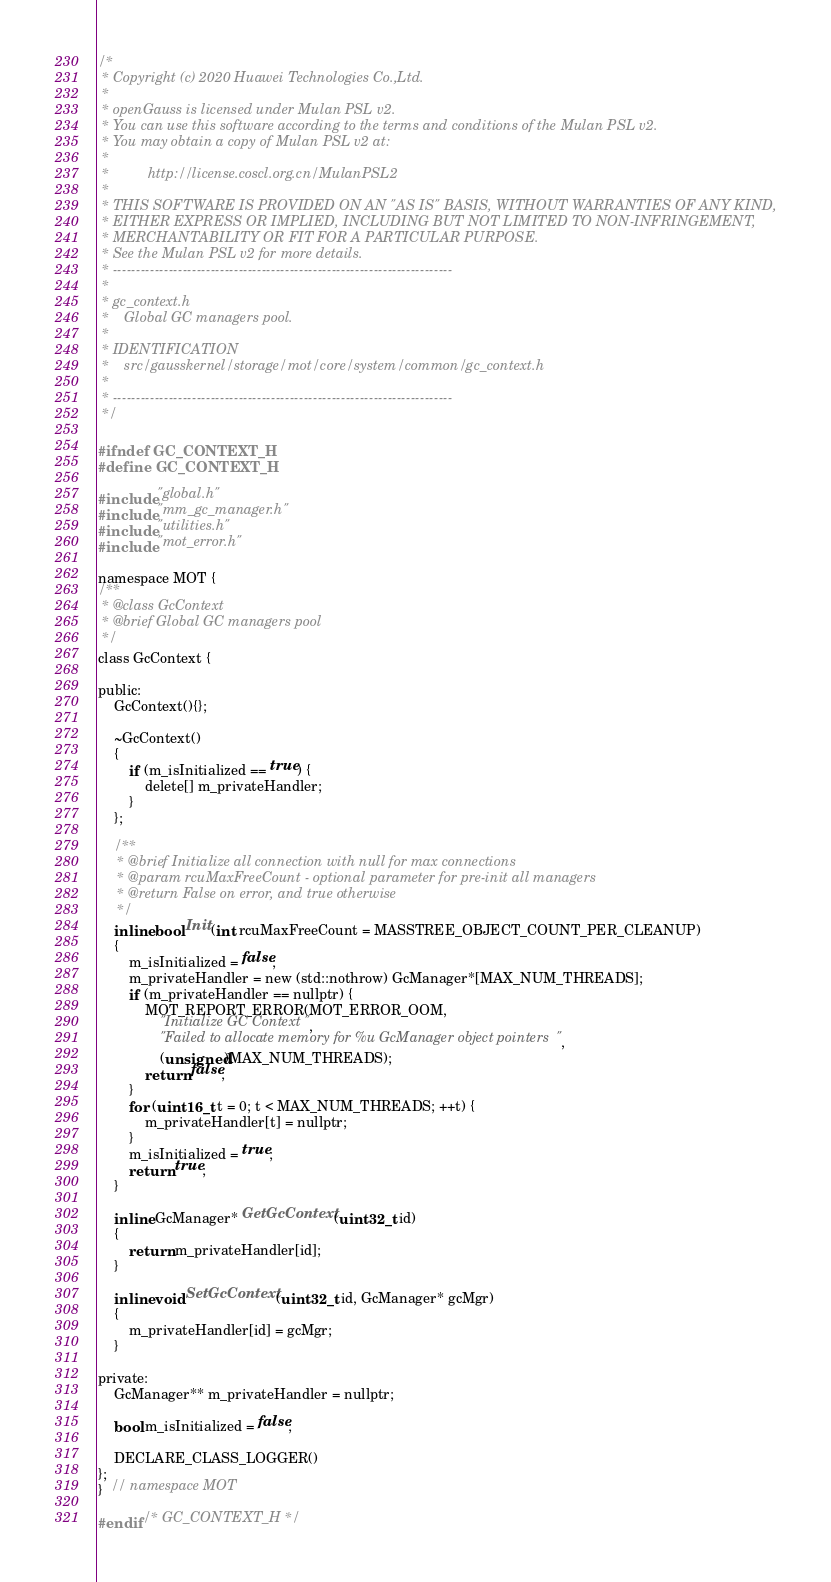<code> <loc_0><loc_0><loc_500><loc_500><_C_>/*
 * Copyright (c) 2020 Huawei Technologies Co.,Ltd.
 *
 * openGauss is licensed under Mulan PSL v2.
 * You can use this software according to the terms and conditions of the Mulan PSL v2.
 * You may obtain a copy of Mulan PSL v2 at:
 *
 *          http://license.coscl.org.cn/MulanPSL2
 *
 * THIS SOFTWARE IS PROVIDED ON AN "AS IS" BASIS, WITHOUT WARRANTIES OF ANY KIND,
 * EITHER EXPRESS OR IMPLIED, INCLUDING BUT NOT LIMITED TO NON-INFRINGEMENT,
 * MERCHANTABILITY OR FIT FOR A PARTICULAR PURPOSE.
 * See the Mulan PSL v2 for more details.
 * -------------------------------------------------------------------------
 *
 * gc_context.h
 *    Global GC managers pool.
 *
 * IDENTIFICATION
 *    src/gausskernel/storage/mot/core/system/common/gc_context.h
 *
 * -------------------------------------------------------------------------
 */

#ifndef GC_CONTEXT_H
#define GC_CONTEXT_H

#include "global.h"
#include "mm_gc_manager.h"
#include "utilities.h"
#include "mot_error.h"

namespace MOT {
/**
 * @class GcContext
 * @brief Global GC managers pool
 */
class GcContext {

public:
    GcContext(){};

    ~GcContext()
    {
        if (m_isInitialized == true) {
            delete[] m_privateHandler;
        }
    };

    /**
     * @brief Initialize all connection with null for max connections
     * @param rcuMaxFreeCount - optional parameter for pre-init all managers
     * @return False on error, and true otherwise
     */
    inline bool Init(int rcuMaxFreeCount = MASSTREE_OBJECT_COUNT_PER_CLEANUP)
    {
        m_isInitialized = false;
        m_privateHandler = new (std::nothrow) GcManager*[MAX_NUM_THREADS];
        if (m_privateHandler == nullptr) {
            MOT_REPORT_ERROR(MOT_ERROR_OOM,
                "Initialize GC Context",
                "Failed to allocate memory for %u GcManager object pointers",
                (unsigned)MAX_NUM_THREADS);
            return false;
        }
        for (uint16_t t = 0; t < MAX_NUM_THREADS; ++t) {
            m_privateHandler[t] = nullptr;
        }
        m_isInitialized = true;
        return true;
    }

    inline GcManager* GetGcContext(uint32_t id)
    {
        return m_privateHandler[id];
    }

    inline void SetGcContext(uint32_t id, GcManager* gcMgr)
    {
        m_privateHandler[id] = gcMgr;
    }

private:
    GcManager** m_privateHandler = nullptr;

    bool m_isInitialized = false;

    DECLARE_CLASS_LOGGER()
};
}  // namespace MOT

#endif /* GC_CONTEXT_H */
</code> 